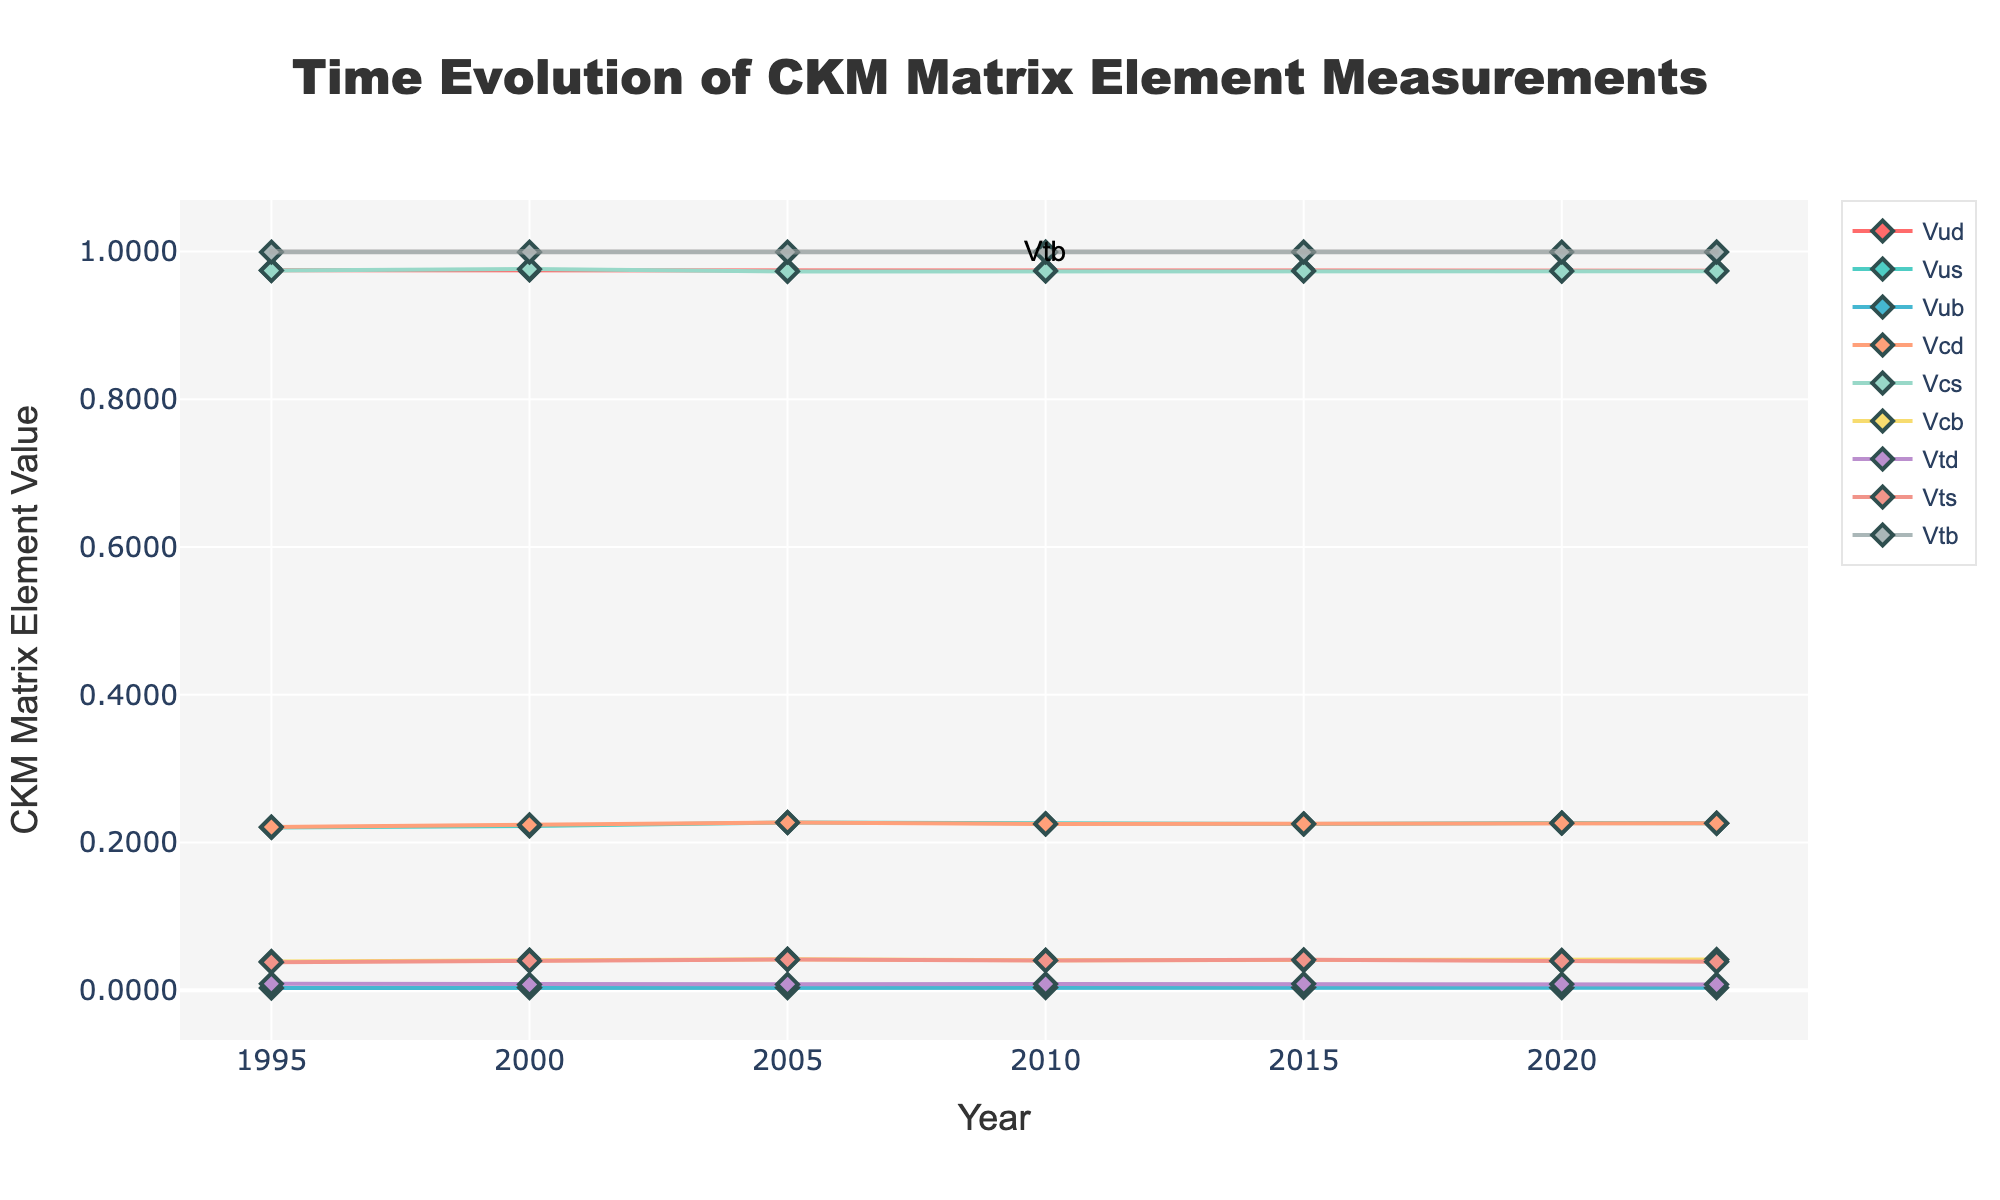What are the years where the value of Vud is exactly 0.97370? To determine the years where the value of Vud is exactly 0.97370, look at the point corresponding to the trace for Vud and note the year when the y-value is 0.97370.
Answer: 2023 Which CKM matrix element shows a value closest to 0.9991 in the year 2020? To determine the CKM matrix element with a value closest to 0.9991 in 2020, look at the year 2020 on the x-axis and identify the trace that is nearest to 0.9991 on the y-axis.
Answer: Vtb Is there any CKM matrix element that shows a decreasing trend from 2010 to 2023? To identify if a CKM matrix element shows a decreasing trend, look at the traces from 2010 to 2023 and observe if values decrease over this period.
Answer: Vtd What's the average value of Vus from 1995 to 2023? Sum the values of Vus for each year listed (0.2205 + 0.2225 + 0.22720 + 0.22543 + 0.22506 + 0.22650 + 0.22621) and divide by the number of years (7).
Answer: 0.22449 Which CKM matrix element has the smallest value change from 1995 to 2023? Calculate the difference between the values in 1995 and 2023 for each CKM matrix element. Identify the one with the smallest absolute difference.
Answer: Vtb Between Vcs and Vcb, which CKM matrix element has higher values consistently over the period from 1995 to 2023? Compare the values of Vcs and Vcb in each year and determine which one is consistently higher throughout the entire period.
Answer: Vcs How many CKM matrix elements have values greater than 0.04 in the year 2023? Identify the values of each CKM matrix element in 2023 and count how many are greater than 0.04.
Answer: 4 (Vcb, Vcs, Vcd, Vts) Which CKM matrix element shows the largest increase in value from 1995 to 2005? Calculate the difference between the value in 1995 and 2005 for each CKM matrix element. Identifty the one with the largest positive value difference.
Answer: Vus What is the range of the Vub value from 1995 to 2023? Identify the minimum and maximum values of Vub from 1995 to 2023 and subtract the minimum value from the maximum value.
Answer: 0.00089 (Max: 0.00409, Min: 0.0032) Are there any CKM matrix elements that cross each other between 2005 and 2010? Examine the plots for overlaps or points where the lines cross each other in the period between 2005 and 2010.
Answer: No 